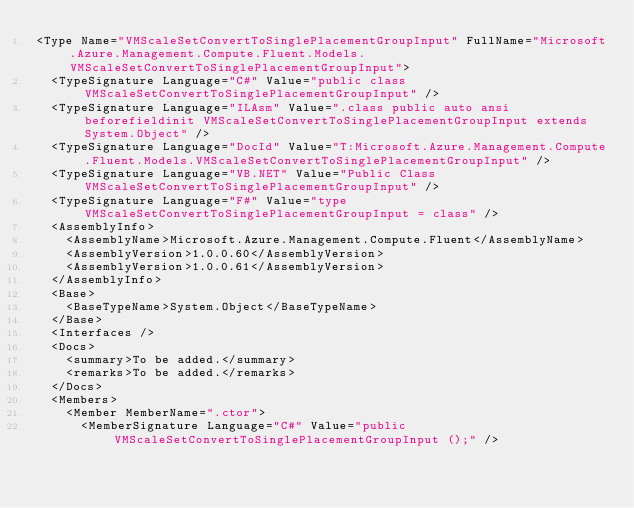Convert code to text. <code><loc_0><loc_0><loc_500><loc_500><_XML_><Type Name="VMScaleSetConvertToSinglePlacementGroupInput" FullName="Microsoft.Azure.Management.Compute.Fluent.Models.VMScaleSetConvertToSinglePlacementGroupInput">
  <TypeSignature Language="C#" Value="public class VMScaleSetConvertToSinglePlacementGroupInput" />
  <TypeSignature Language="ILAsm" Value=".class public auto ansi beforefieldinit VMScaleSetConvertToSinglePlacementGroupInput extends System.Object" />
  <TypeSignature Language="DocId" Value="T:Microsoft.Azure.Management.Compute.Fluent.Models.VMScaleSetConvertToSinglePlacementGroupInput" />
  <TypeSignature Language="VB.NET" Value="Public Class VMScaleSetConvertToSinglePlacementGroupInput" />
  <TypeSignature Language="F#" Value="type VMScaleSetConvertToSinglePlacementGroupInput = class" />
  <AssemblyInfo>
    <AssemblyName>Microsoft.Azure.Management.Compute.Fluent</AssemblyName>
    <AssemblyVersion>1.0.0.60</AssemblyVersion>
    <AssemblyVersion>1.0.0.61</AssemblyVersion>
  </AssemblyInfo>
  <Base>
    <BaseTypeName>System.Object</BaseTypeName>
  </Base>
  <Interfaces />
  <Docs>
    <summary>To be added.</summary>
    <remarks>To be added.</remarks>
  </Docs>
  <Members>
    <Member MemberName=".ctor">
      <MemberSignature Language="C#" Value="public VMScaleSetConvertToSinglePlacementGroupInput ();" /></code> 